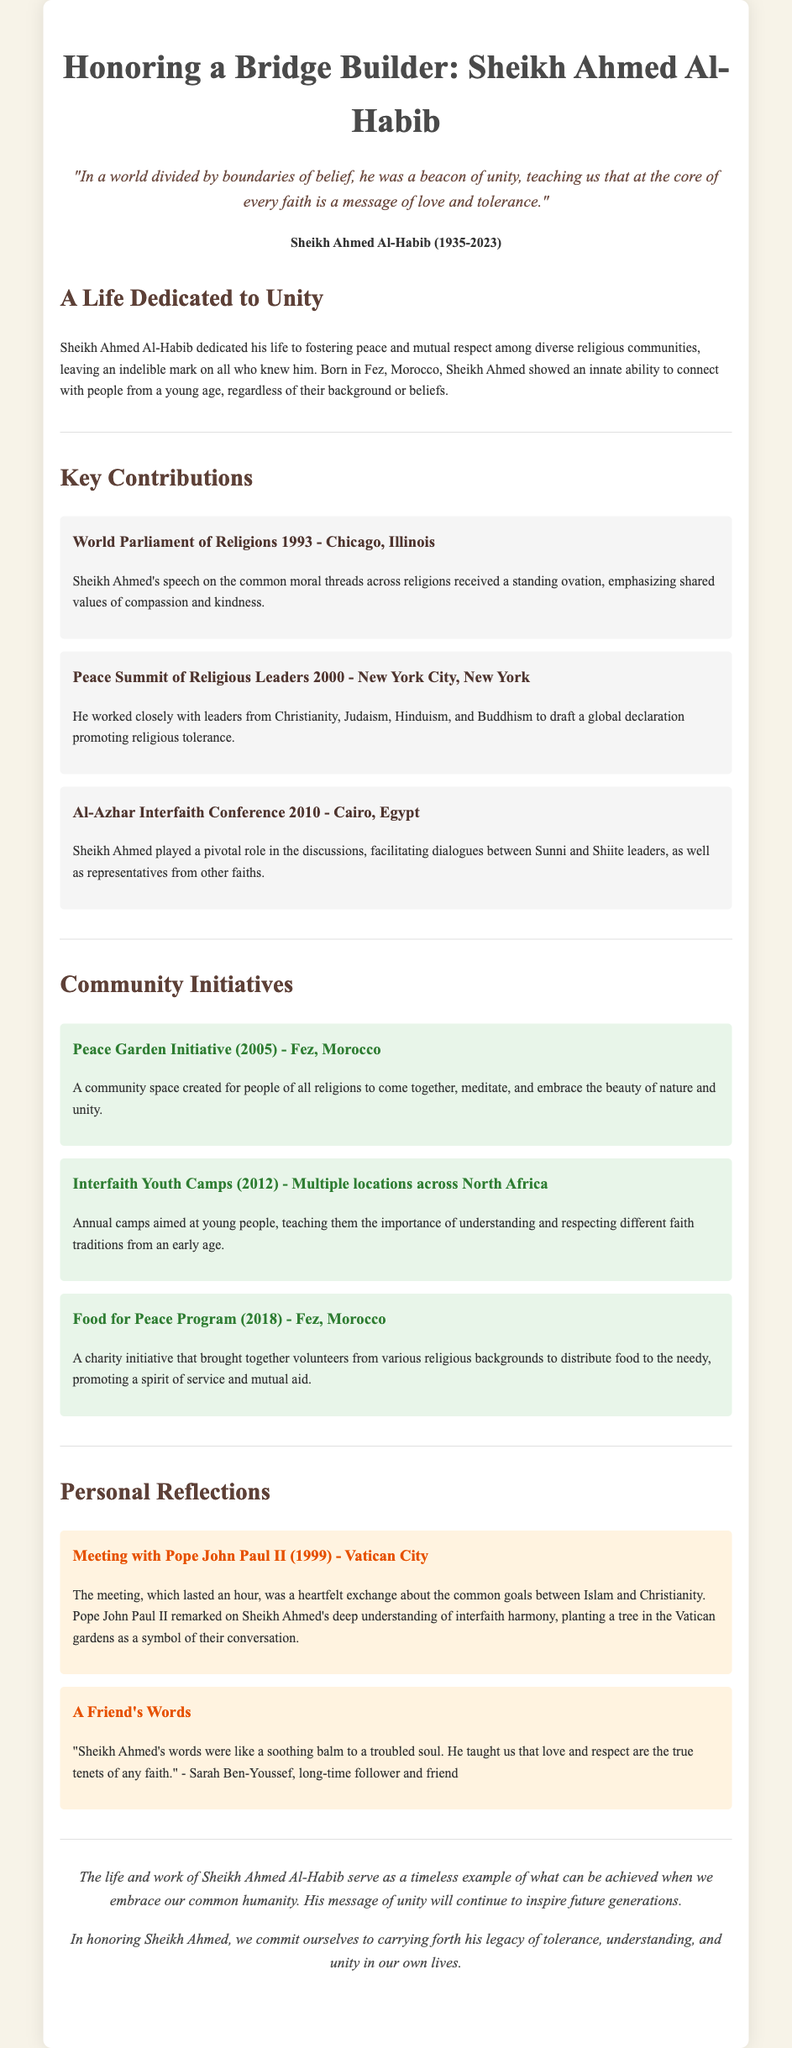what was the Sheikh's birth year? The document states that Sheikh Ahmed Al-Habib was born in 1935.
Answer: 1935 where was the Peace Garden Initiative created? The Peace Garden Initiative was created in Fez, Morocco.
Answer: Fez, Morocco what significant interfaith meeting took place in 2010? The significant interfaith meeting that took place in 2010 was the Al-Azhar Interfaith Conference.
Answer: Al-Azhar Interfaith Conference who did Sheikh Ahmed meet with in 1999? In 1999, Sheikh Ahmed met with Pope John Paul II.
Answer: Pope John Paul II which project aimed at young people was initiated in 2012? The project aimed at young people that was initiated in 2012 is the Interfaith Youth Camps.
Answer: Interfaith Youth Camps what was a common theme in Sheikh Ahmed's speeches? A common theme in Sheikh Ahmed's speeches was shared values of compassion and kindness.
Answer: compassion and kindness how did Sheikh Ahmed contribute to the Peace Summit in 2000? He worked closely with leaders from different religions to draft a global declaration promoting religious tolerance.
Answer: draft a global declaration what year did Sheikh Ahmed pass away? The document states that Sheikh Ahmed Al-Habib passed away in 2023.
Answer: 2023 which initiative brought together volunteers from various religious backgrounds in 2018? The initiative that brought together volunteers in 2018 is the Food for Peace Program.
Answer: Food for Peace Program 